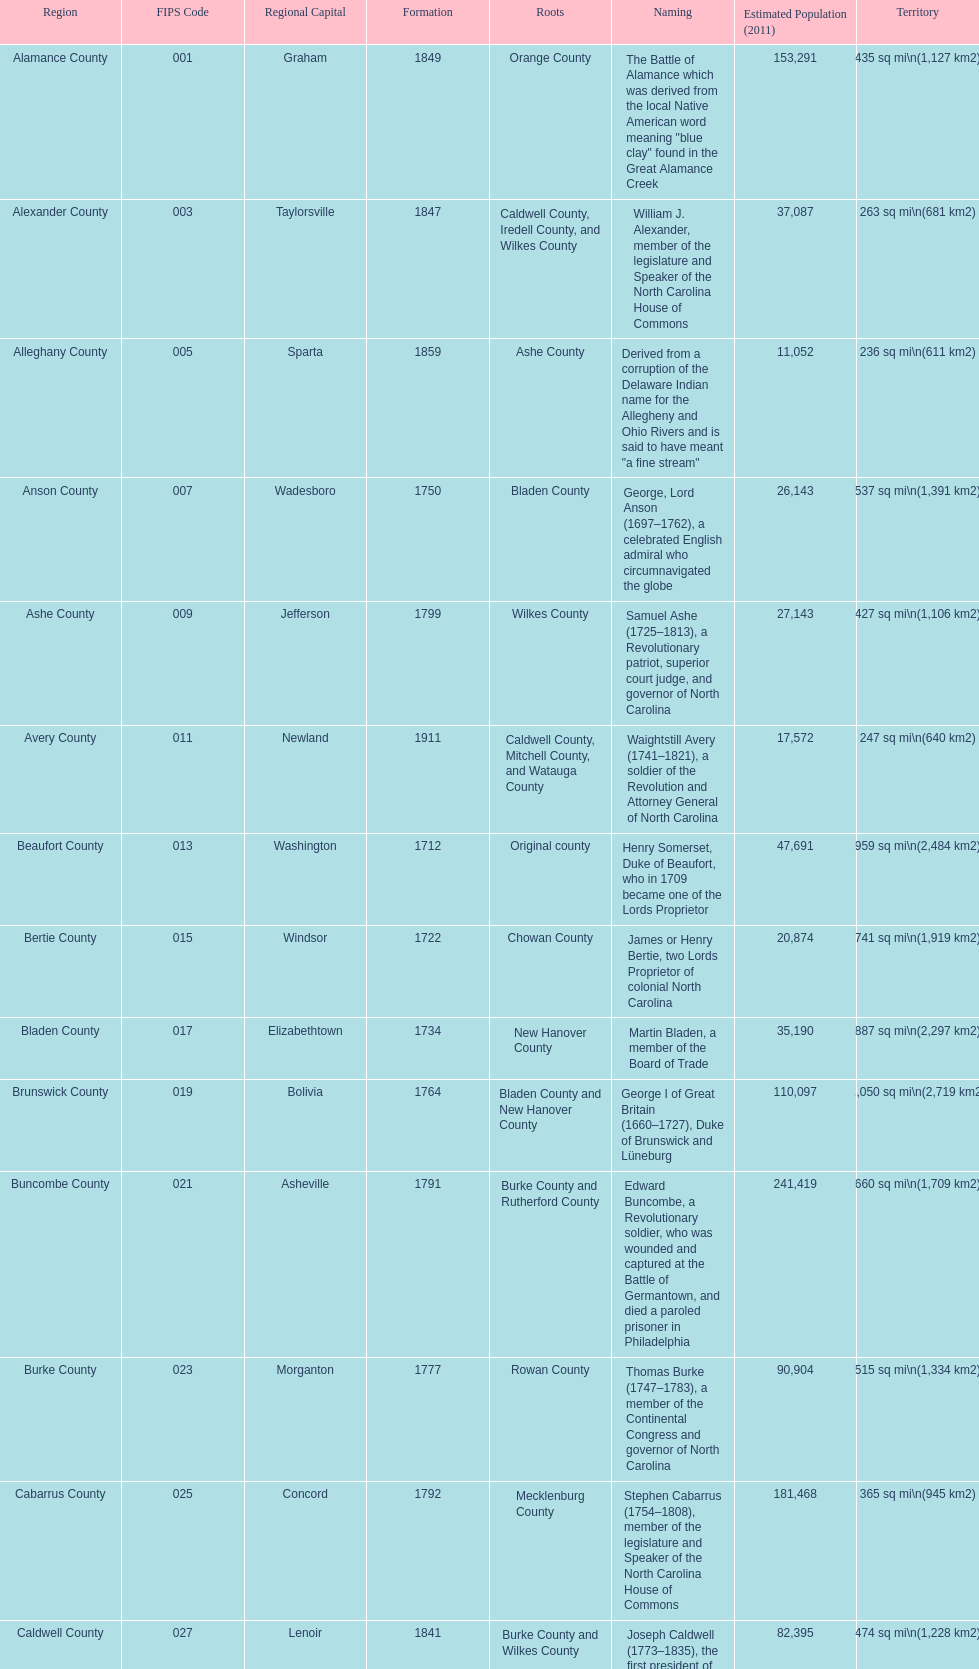Which county covers the most area? Dare County. 